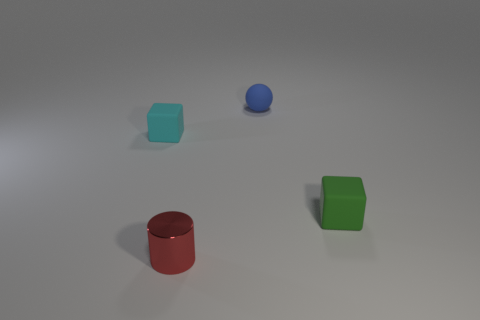The small green object that is the same material as the tiny cyan thing is what shape?
Provide a succinct answer. Cube. There is a cube that is right of the cylinder; is its size the same as the cube on the left side of the metal thing?
Provide a succinct answer. Yes. What is the shape of the matte object that is to the left of the blue sphere?
Give a very brief answer. Cube. What color is the cylinder?
Make the answer very short. Red. How many shiny things are either brown cubes or small cyan blocks?
Provide a succinct answer. 0. Is there anything else that is the same material as the red object?
Offer a terse response. No. What shape is the small blue matte object?
Offer a very short reply. Sphere. What is the size of the matte thing behind the small block behind the tiny block that is on the right side of the tiny blue thing?
Offer a terse response. Small. What number of other objects are the same shape as the tiny cyan matte thing?
Provide a short and direct response. 1. Do the object that is on the right side of the blue matte thing and the tiny red thing that is in front of the small blue thing have the same shape?
Your response must be concise. No. 